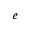<formula> <loc_0><loc_0><loc_500><loc_500>e</formula> 